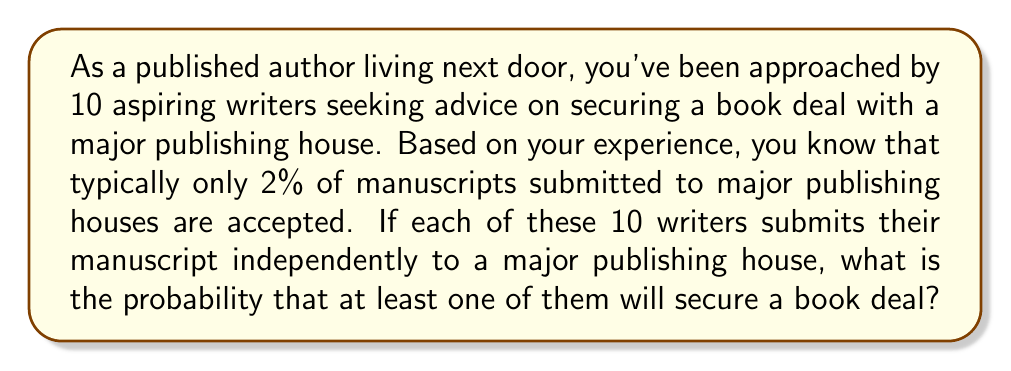Can you answer this question? Let's approach this step-by-step:

1) First, we need to calculate the probability of a single writer not securing a book deal. If the probability of success is 2%, then the probability of failure is:

   $1 - 0.02 = 0.98$ or 98%

2) Now, we need to calculate the probability of all 10 writers failing to secure a deal. Since each submission is independent, we can use the multiplication rule of probability:

   $P(\text{all fail}) = 0.98^{10}$

3) To calculate this:

   $0.98^{10} \approx 0.8179$

4) This gives us the probability that none of the 10 writers secure a deal. But we want the probability that at least one succeeds. This is the complement of the probability we just calculated:

   $P(\text{at least one succeeds}) = 1 - P(\text{all fail})$

5) Therefore:

   $P(\text{at least one succeeds}) = 1 - 0.8179 \approx 0.1821$

6) We can express this as a percentage:

   $0.1821 \times 100\% \approx 18.21\%$

Thus, there is approximately an 18.21% chance that at least one of the 10 writers will secure a book deal with a major publishing house.
Answer: $18.21\%$ or $0.1821$ 